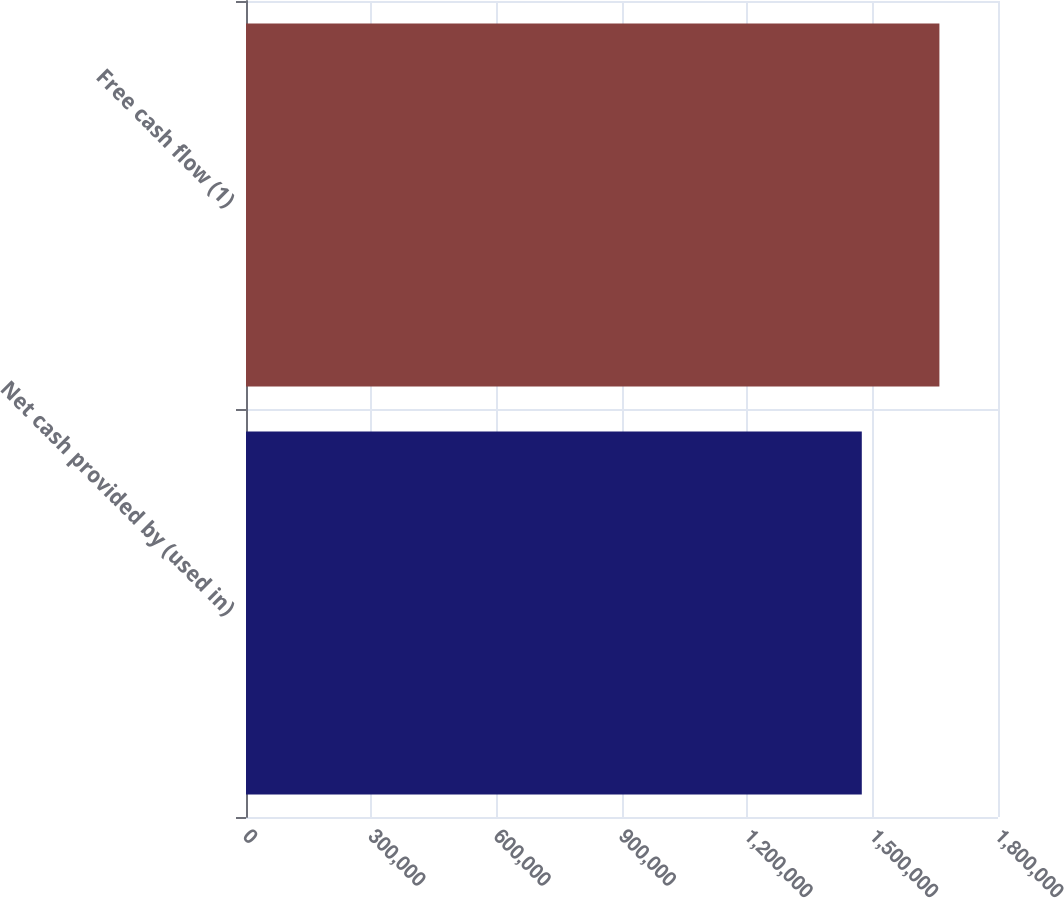<chart> <loc_0><loc_0><loc_500><loc_500><bar_chart><fcel>Net cash provided by (used in)<fcel>Free cash flow (1)<nl><fcel>1.47398e+06<fcel>1.65976e+06<nl></chart> 